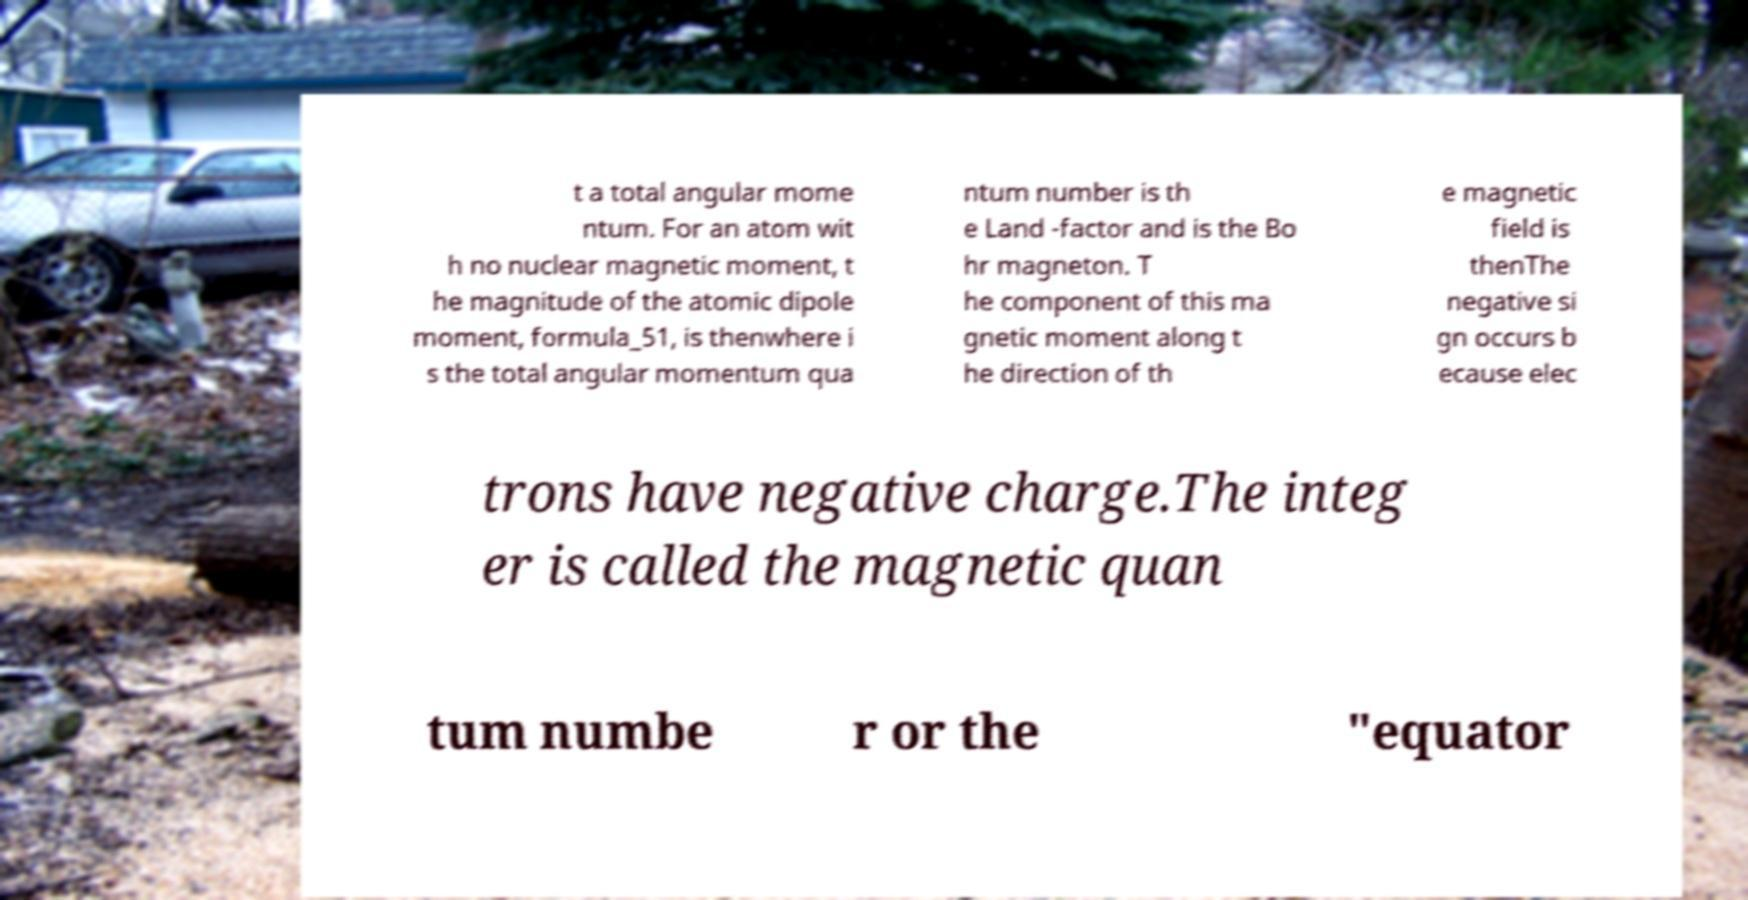Can you read and provide the text displayed in the image?This photo seems to have some interesting text. Can you extract and type it out for me? t a total angular mome ntum. For an atom wit h no nuclear magnetic moment, t he magnitude of the atomic dipole moment, formula_51, is thenwhere i s the total angular momentum qua ntum number is th e Land -factor and is the Bo hr magneton. T he component of this ma gnetic moment along t he direction of th e magnetic field is thenThe negative si gn occurs b ecause elec trons have negative charge.The integ er is called the magnetic quan tum numbe r or the "equator 